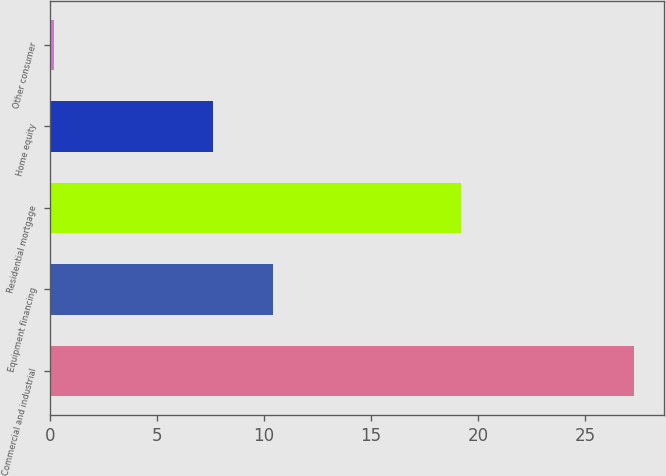<chart> <loc_0><loc_0><loc_500><loc_500><bar_chart><fcel>Commercial and industrial<fcel>Equipment financing<fcel>Residential mortgage<fcel>Home equity<fcel>Other consumer<nl><fcel>27.3<fcel>10.4<fcel>19.2<fcel>7.6<fcel>0.2<nl></chart> 